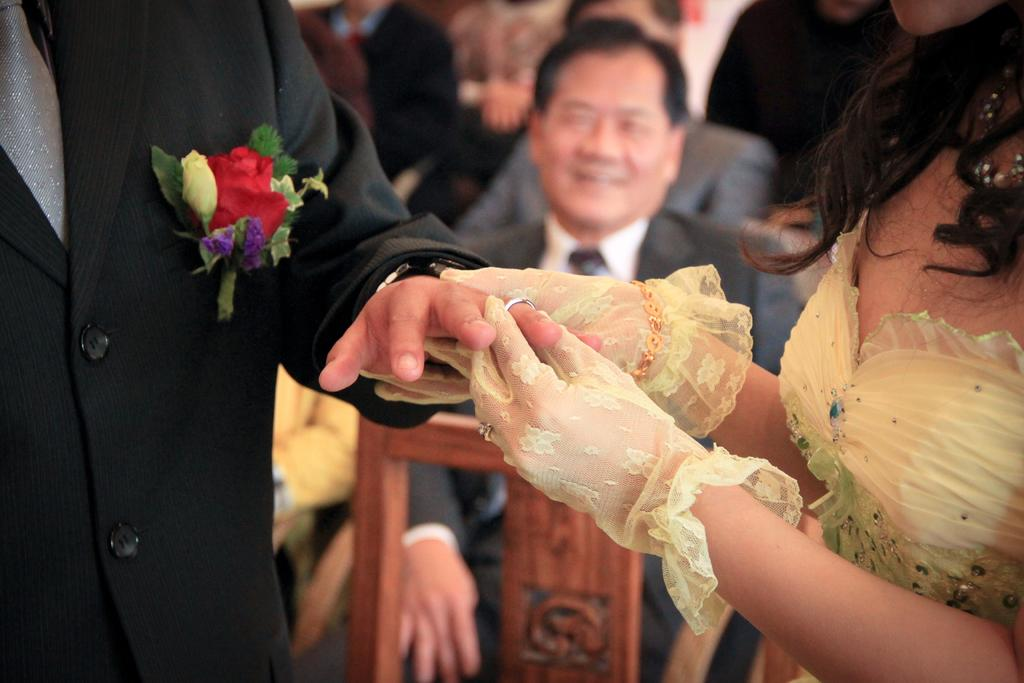How many people are present in the image? There are two persons standing in the image. What are the two persons doing in the image? One person is putting a ring on another person's finger. Can you describe the background of the image? There is a group of people sitting in the background of the image. What type of nation is depicted in the image? There is no nation depicted in the image; it features two persons and a group of people sitting in the background. Can you tell me how many turkeys are present in the image? There are no turkeys present in the image. 